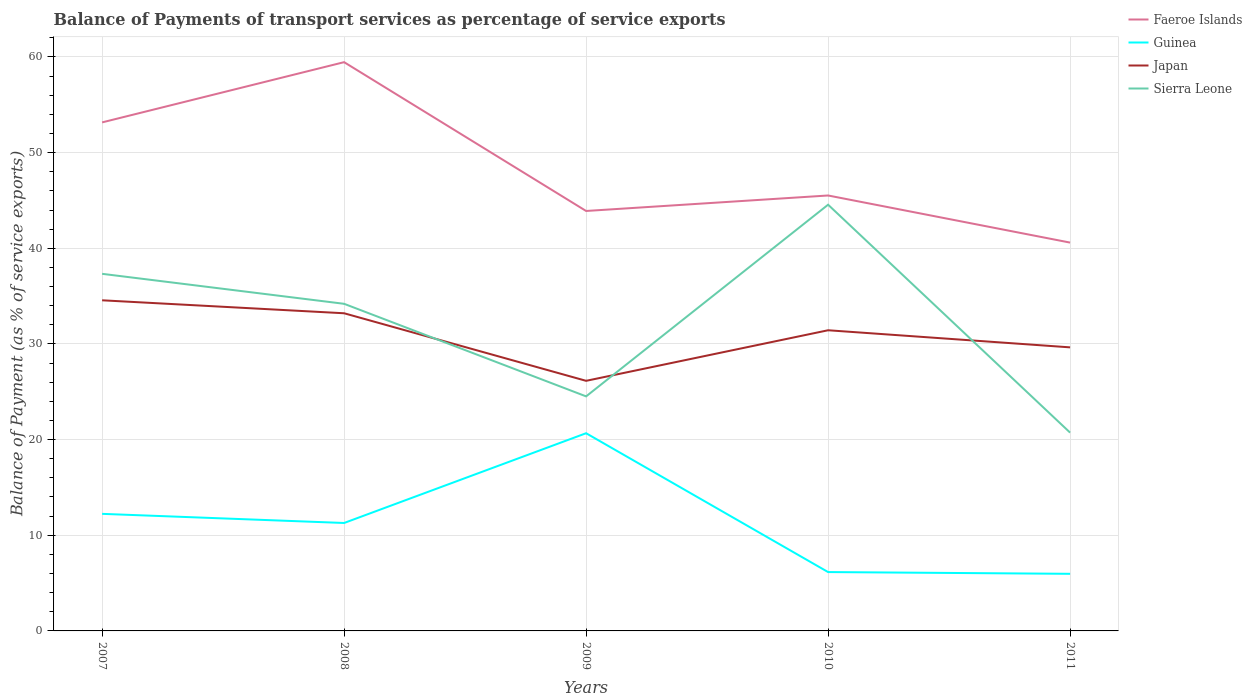Does the line corresponding to Sierra Leone intersect with the line corresponding to Japan?
Provide a succinct answer. Yes. Across all years, what is the maximum balance of payments of transport services in Sierra Leone?
Offer a terse response. 20.73. In which year was the balance of payments of transport services in Faeroe Islands maximum?
Provide a succinct answer. 2011. What is the total balance of payments of transport services in Japan in the graph?
Provide a short and direct response. 8.42. What is the difference between the highest and the second highest balance of payments of transport services in Guinea?
Keep it short and to the point. 14.7. Is the balance of payments of transport services in Guinea strictly greater than the balance of payments of transport services in Faeroe Islands over the years?
Provide a short and direct response. Yes. What is the difference between two consecutive major ticks on the Y-axis?
Provide a short and direct response. 10. How many legend labels are there?
Make the answer very short. 4. How are the legend labels stacked?
Keep it short and to the point. Vertical. What is the title of the graph?
Provide a succinct answer. Balance of Payments of transport services as percentage of service exports. Does "Nicaragua" appear as one of the legend labels in the graph?
Make the answer very short. No. What is the label or title of the X-axis?
Your response must be concise. Years. What is the label or title of the Y-axis?
Your answer should be very brief. Balance of Payment (as % of service exports). What is the Balance of Payment (as % of service exports) of Faeroe Islands in 2007?
Provide a succinct answer. 53.16. What is the Balance of Payment (as % of service exports) in Guinea in 2007?
Your answer should be compact. 12.24. What is the Balance of Payment (as % of service exports) in Japan in 2007?
Provide a short and direct response. 34.56. What is the Balance of Payment (as % of service exports) in Sierra Leone in 2007?
Offer a terse response. 37.33. What is the Balance of Payment (as % of service exports) of Faeroe Islands in 2008?
Make the answer very short. 59.46. What is the Balance of Payment (as % of service exports) in Guinea in 2008?
Offer a terse response. 11.28. What is the Balance of Payment (as % of service exports) in Japan in 2008?
Give a very brief answer. 33.21. What is the Balance of Payment (as % of service exports) in Sierra Leone in 2008?
Give a very brief answer. 34.2. What is the Balance of Payment (as % of service exports) of Faeroe Islands in 2009?
Your answer should be very brief. 43.9. What is the Balance of Payment (as % of service exports) in Guinea in 2009?
Keep it short and to the point. 20.67. What is the Balance of Payment (as % of service exports) in Japan in 2009?
Your response must be concise. 26.14. What is the Balance of Payment (as % of service exports) of Sierra Leone in 2009?
Your answer should be very brief. 24.52. What is the Balance of Payment (as % of service exports) in Faeroe Islands in 2010?
Your response must be concise. 45.52. What is the Balance of Payment (as % of service exports) in Guinea in 2010?
Keep it short and to the point. 6.15. What is the Balance of Payment (as % of service exports) in Japan in 2010?
Your answer should be compact. 31.43. What is the Balance of Payment (as % of service exports) in Sierra Leone in 2010?
Make the answer very short. 44.56. What is the Balance of Payment (as % of service exports) of Faeroe Islands in 2011?
Your answer should be compact. 40.59. What is the Balance of Payment (as % of service exports) in Guinea in 2011?
Make the answer very short. 5.97. What is the Balance of Payment (as % of service exports) of Japan in 2011?
Ensure brevity in your answer.  29.64. What is the Balance of Payment (as % of service exports) of Sierra Leone in 2011?
Provide a short and direct response. 20.73. Across all years, what is the maximum Balance of Payment (as % of service exports) of Faeroe Islands?
Give a very brief answer. 59.46. Across all years, what is the maximum Balance of Payment (as % of service exports) of Guinea?
Offer a terse response. 20.67. Across all years, what is the maximum Balance of Payment (as % of service exports) in Japan?
Your answer should be very brief. 34.56. Across all years, what is the maximum Balance of Payment (as % of service exports) of Sierra Leone?
Your answer should be very brief. 44.56. Across all years, what is the minimum Balance of Payment (as % of service exports) of Faeroe Islands?
Make the answer very short. 40.59. Across all years, what is the minimum Balance of Payment (as % of service exports) of Guinea?
Make the answer very short. 5.97. Across all years, what is the minimum Balance of Payment (as % of service exports) in Japan?
Offer a terse response. 26.14. Across all years, what is the minimum Balance of Payment (as % of service exports) in Sierra Leone?
Your answer should be compact. 20.73. What is the total Balance of Payment (as % of service exports) of Faeroe Islands in the graph?
Your answer should be compact. 242.63. What is the total Balance of Payment (as % of service exports) of Guinea in the graph?
Ensure brevity in your answer.  56.31. What is the total Balance of Payment (as % of service exports) in Japan in the graph?
Your answer should be very brief. 154.99. What is the total Balance of Payment (as % of service exports) in Sierra Leone in the graph?
Make the answer very short. 161.33. What is the difference between the Balance of Payment (as % of service exports) in Faeroe Islands in 2007 and that in 2008?
Keep it short and to the point. -6.3. What is the difference between the Balance of Payment (as % of service exports) in Guinea in 2007 and that in 2008?
Your answer should be very brief. 0.96. What is the difference between the Balance of Payment (as % of service exports) in Japan in 2007 and that in 2008?
Ensure brevity in your answer.  1.36. What is the difference between the Balance of Payment (as % of service exports) of Sierra Leone in 2007 and that in 2008?
Make the answer very short. 3.14. What is the difference between the Balance of Payment (as % of service exports) of Faeroe Islands in 2007 and that in 2009?
Your response must be concise. 9.26. What is the difference between the Balance of Payment (as % of service exports) of Guinea in 2007 and that in 2009?
Your answer should be compact. -8.43. What is the difference between the Balance of Payment (as % of service exports) in Japan in 2007 and that in 2009?
Provide a short and direct response. 8.42. What is the difference between the Balance of Payment (as % of service exports) of Sierra Leone in 2007 and that in 2009?
Offer a very short reply. 12.81. What is the difference between the Balance of Payment (as % of service exports) of Faeroe Islands in 2007 and that in 2010?
Your answer should be very brief. 7.64. What is the difference between the Balance of Payment (as % of service exports) of Guinea in 2007 and that in 2010?
Provide a short and direct response. 6.09. What is the difference between the Balance of Payment (as % of service exports) of Japan in 2007 and that in 2010?
Keep it short and to the point. 3.13. What is the difference between the Balance of Payment (as % of service exports) of Sierra Leone in 2007 and that in 2010?
Offer a very short reply. -7.22. What is the difference between the Balance of Payment (as % of service exports) in Faeroe Islands in 2007 and that in 2011?
Offer a terse response. 12.57. What is the difference between the Balance of Payment (as % of service exports) in Guinea in 2007 and that in 2011?
Your answer should be compact. 6.27. What is the difference between the Balance of Payment (as % of service exports) in Japan in 2007 and that in 2011?
Offer a terse response. 4.92. What is the difference between the Balance of Payment (as % of service exports) in Sierra Leone in 2007 and that in 2011?
Offer a very short reply. 16.6. What is the difference between the Balance of Payment (as % of service exports) in Faeroe Islands in 2008 and that in 2009?
Give a very brief answer. 15.56. What is the difference between the Balance of Payment (as % of service exports) in Guinea in 2008 and that in 2009?
Ensure brevity in your answer.  -9.38. What is the difference between the Balance of Payment (as % of service exports) in Japan in 2008 and that in 2009?
Keep it short and to the point. 7.06. What is the difference between the Balance of Payment (as % of service exports) of Sierra Leone in 2008 and that in 2009?
Your response must be concise. 9.68. What is the difference between the Balance of Payment (as % of service exports) of Faeroe Islands in 2008 and that in 2010?
Offer a terse response. 13.94. What is the difference between the Balance of Payment (as % of service exports) in Guinea in 2008 and that in 2010?
Offer a very short reply. 5.13. What is the difference between the Balance of Payment (as % of service exports) in Japan in 2008 and that in 2010?
Give a very brief answer. 1.78. What is the difference between the Balance of Payment (as % of service exports) in Sierra Leone in 2008 and that in 2010?
Keep it short and to the point. -10.36. What is the difference between the Balance of Payment (as % of service exports) of Faeroe Islands in 2008 and that in 2011?
Offer a very short reply. 18.86. What is the difference between the Balance of Payment (as % of service exports) in Guinea in 2008 and that in 2011?
Provide a short and direct response. 5.31. What is the difference between the Balance of Payment (as % of service exports) in Japan in 2008 and that in 2011?
Make the answer very short. 3.56. What is the difference between the Balance of Payment (as % of service exports) in Sierra Leone in 2008 and that in 2011?
Ensure brevity in your answer.  13.47. What is the difference between the Balance of Payment (as % of service exports) of Faeroe Islands in 2009 and that in 2010?
Keep it short and to the point. -1.62. What is the difference between the Balance of Payment (as % of service exports) in Guinea in 2009 and that in 2010?
Ensure brevity in your answer.  14.51. What is the difference between the Balance of Payment (as % of service exports) of Japan in 2009 and that in 2010?
Make the answer very short. -5.29. What is the difference between the Balance of Payment (as % of service exports) of Sierra Leone in 2009 and that in 2010?
Your response must be concise. -20.04. What is the difference between the Balance of Payment (as % of service exports) in Faeroe Islands in 2009 and that in 2011?
Provide a succinct answer. 3.31. What is the difference between the Balance of Payment (as % of service exports) of Guinea in 2009 and that in 2011?
Keep it short and to the point. 14.7. What is the difference between the Balance of Payment (as % of service exports) in Japan in 2009 and that in 2011?
Give a very brief answer. -3.5. What is the difference between the Balance of Payment (as % of service exports) in Sierra Leone in 2009 and that in 2011?
Ensure brevity in your answer.  3.79. What is the difference between the Balance of Payment (as % of service exports) in Faeroe Islands in 2010 and that in 2011?
Keep it short and to the point. 4.92. What is the difference between the Balance of Payment (as % of service exports) in Guinea in 2010 and that in 2011?
Provide a succinct answer. 0.18. What is the difference between the Balance of Payment (as % of service exports) of Japan in 2010 and that in 2011?
Your answer should be very brief. 1.79. What is the difference between the Balance of Payment (as % of service exports) of Sierra Leone in 2010 and that in 2011?
Ensure brevity in your answer.  23.83. What is the difference between the Balance of Payment (as % of service exports) of Faeroe Islands in 2007 and the Balance of Payment (as % of service exports) of Guinea in 2008?
Ensure brevity in your answer.  41.88. What is the difference between the Balance of Payment (as % of service exports) in Faeroe Islands in 2007 and the Balance of Payment (as % of service exports) in Japan in 2008?
Your response must be concise. 19.95. What is the difference between the Balance of Payment (as % of service exports) in Faeroe Islands in 2007 and the Balance of Payment (as % of service exports) in Sierra Leone in 2008?
Offer a terse response. 18.96. What is the difference between the Balance of Payment (as % of service exports) of Guinea in 2007 and the Balance of Payment (as % of service exports) of Japan in 2008?
Keep it short and to the point. -20.97. What is the difference between the Balance of Payment (as % of service exports) in Guinea in 2007 and the Balance of Payment (as % of service exports) in Sierra Leone in 2008?
Offer a terse response. -21.96. What is the difference between the Balance of Payment (as % of service exports) of Japan in 2007 and the Balance of Payment (as % of service exports) of Sierra Leone in 2008?
Your response must be concise. 0.37. What is the difference between the Balance of Payment (as % of service exports) in Faeroe Islands in 2007 and the Balance of Payment (as % of service exports) in Guinea in 2009?
Provide a short and direct response. 32.49. What is the difference between the Balance of Payment (as % of service exports) of Faeroe Islands in 2007 and the Balance of Payment (as % of service exports) of Japan in 2009?
Your answer should be very brief. 27.02. What is the difference between the Balance of Payment (as % of service exports) in Faeroe Islands in 2007 and the Balance of Payment (as % of service exports) in Sierra Leone in 2009?
Keep it short and to the point. 28.64. What is the difference between the Balance of Payment (as % of service exports) of Guinea in 2007 and the Balance of Payment (as % of service exports) of Japan in 2009?
Ensure brevity in your answer.  -13.91. What is the difference between the Balance of Payment (as % of service exports) in Guinea in 2007 and the Balance of Payment (as % of service exports) in Sierra Leone in 2009?
Your answer should be compact. -12.28. What is the difference between the Balance of Payment (as % of service exports) in Japan in 2007 and the Balance of Payment (as % of service exports) in Sierra Leone in 2009?
Give a very brief answer. 10.04. What is the difference between the Balance of Payment (as % of service exports) in Faeroe Islands in 2007 and the Balance of Payment (as % of service exports) in Guinea in 2010?
Your answer should be very brief. 47.01. What is the difference between the Balance of Payment (as % of service exports) in Faeroe Islands in 2007 and the Balance of Payment (as % of service exports) in Japan in 2010?
Offer a very short reply. 21.73. What is the difference between the Balance of Payment (as % of service exports) of Faeroe Islands in 2007 and the Balance of Payment (as % of service exports) of Sierra Leone in 2010?
Ensure brevity in your answer.  8.6. What is the difference between the Balance of Payment (as % of service exports) of Guinea in 2007 and the Balance of Payment (as % of service exports) of Japan in 2010?
Your answer should be compact. -19.19. What is the difference between the Balance of Payment (as % of service exports) of Guinea in 2007 and the Balance of Payment (as % of service exports) of Sierra Leone in 2010?
Give a very brief answer. -32.32. What is the difference between the Balance of Payment (as % of service exports) of Japan in 2007 and the Balance of Payment (as % of service exports) of Sierra Leone in 2010?
Make the answer very short. -9.99. What is the difference between the Balance of Payment (as % of service exports) of Faeroe Islands in 2007 and the Balance of Payment (as % of service exports) of Guinea in 2011?
Your response must be concise. 47.19. What is the difference between the Balance of Payment (as % of service exports) of Faeroe Islands in 2007 and the Balance of Payment (as % of service exports) of Japan in 2011?
Provide a short and direct response. 23.52. What is the difference between the Balance of Payment (as % of service exports) of Faeroe Islands in 2007 and the Balance of Payment (as % of service exports) of Sierra Leone in 2011?
Provide a succinct answer. 32.43. What is the difference between the Balance of Payment (as % of service exports) in Guinea in 2007 and the Balance of Payment (as % of service exports) in Japan in 2011?
Ensure brevity in your answer.  -17.4. What is the difference between the Balance of Payment (as % of service exports) of Guinea in 2007 and the Balance of Payment (as % of service exports) of Sierra Leone in 2011?
Provide a short and direct response. -8.49. What is the difference between the Balance of Payment (as % of service exports) of Japan in 2007 and the Balance of Payment (as % of service exports) of Sierra Leone in 2011?
Give a very brief answer. 13.83. What is the difference between the Balance of Payment (as % of service exports) in Faeroe Islands in 2008 and the Balance of Payment (as % of service exports) in Guinea in 2009?
Offer a very short reply. 38.79. What is the difference between the Balance of Payment (as % of service exports) in Faeroe Islands in 2008 and the Balance of Payment (as % of service exports) in Japan in 2009?
Offer a very short reply. 33.31. What is the difference between the Balance of Payment (as % of service exports) in Faeroe Islands in 2008 and the Balance of Payment (as % of service exports) in Sierra Leone in 2009?
Provide a succinct answer. 34.94. What is the difference between the Balance of Payment (as % of service exports) of Guinea in 2008 and the Balance of Payment (as % of service exports) of Japan in 2009?
Ensure brevity in your answer.  -14.86. What is the difference between the Balance of Payment (as % of service exports) of Guinea in 2008 and the Balance of Payment (as % of service exports) of Sierra Leone in 2009?
Offer a terse response. -13.24. What is the difference between the Balance of Payment (as % of service exports) in Japan in 2008 and the Balance of Payment (as % of service exports) in Sierra Leone in 2009?
Offer a terse response. 8.69. What is the difference between the Balance of Payment (as % of service exports) of Faeroe Islands in 2008 and the Balance of Payment (as % of service exports) of Guinea in 2010?
Give a very brief answer. 53.3. What is the difference between the Balance of Payment (as % of service exports) of Faeroe Islands in 2008 and the Balance of Payment (as % of service exports) of Japan in 2010?
Offer a very short reply. 28.03. What is the difference between the Balance of Payment (as % of service exports) in Faeroe Islands in 2008 and the Balance of Payment (as % of service exports) in Sierra Leone in 2010?
Your answer should be compact. 14.9. What is the difference between the Balance of Payment (as % of service exports) of Guinea in 2008 and the Balance of Payment (as % of service exports) of Japan in 2010?
Your answer should be compact. -20.15. What is the difference between the Balance of Payment (as % of service exports) of Guinea in 2008 and the Balance of Payment (as % of service exports) of Sierra Leone in 2010?
Keep it short and to the point. -33.27. What is the difference between the Balance of Payment (as % of service exports) of Japan in 2008 and the Balance of Payment (as % of service exports) of Sierra Leone in 2010?
Offer a very short reply. -11.35. What is the difference between the Balance of Payment (as % of service exports) in Faeroe Islands in 2008 and the Balance of Payment (as % of service exports) in Guinea in 2011?
Offer a terse response. 53.49. What is the difference between the Balance of Payment (as % of service exports) of Faeroe Islands in 2008 and the Balance of Payment (as % of service exports) of Japan in 2011?
Offer a very short reply. 29.81. What is the difference between the Balance of Payment (as % of service exports) of Faeroe Islands in 2008 and the Balance of Payment (as % of service exports) of Sierra Leone in 2011?
Your answer should be compact. 38.73. What is the difference between the Balance of Payment (as % of service exports) in Guinea in 2008 and the Balance of Payment (as % of service exports) in Japan in 2011?
Make the answer very short. -18.36. What is the difference between the Balance of Payment (as % of service exports) of Guinea in 2008 and the Balance of Payment (as % of service exports) of Sierra Leone in 2011?
Make the answer very short. -9.45. What is the difference between the Balance of Payment (as % of service exports) of Japan in 2008 and the Balance of Payment (as % of service exports) of Sierra Leone in 2011?
Your response must be concise. 12.48. What is the difference between the Balance of Payment (as % of service exports) of Faeroe Islands in 2009 and the Balance of Payment (as % of service exports) of Guinea in 2010?
Provide a short and direct response. 37.75. What is the difference between the Balance of Payment (as % of service exports) of Faeroe Islands in 2009 and the Balance of Payment (as % of service exports) of Japan in 2010?
Provide a succinct answer. 12.47. What is the difference between the Balance of Payment (as % of service exports) in Faeroe Islands in 2009 and the Balance of Payment (as % of service exports) in Sierra Leone in 2010?
Keep it short and to the point. -0.66. What is the difference between the Balance of Payment (as % of service exports) of Guinea in 2009 and the Balance of Payment (as % of service exports) of Japan in 2010?
Your response must be concise. -10.76. What is the difference between the Balance of Payment (as % of service exports) of Guinea in 2009 and the Balance of Payment (as % of service exports) of Sierra Leone in 2010?
Your response must be concise. -23.89. What is the difference between the Balance of Payment (as % of service exports) of Japan in 2009 and the Balance of Payment (as % of service exports) of Sierra Leone in 2010?
Ensure brevity in your answer.  -18.41. What is the difference between the Balance of Payment (as % of service exports) in Faeroe Islands in 2009 and the Balance of Payment (as % of service exports) in Guinea in 2011?
Provide a succinct answer. 37.93. What is the difference between the Balance of Payment (as % of service exports) in Faeroe Islands in 2009 and the Balance of Payment (as % of service exports) in Japan in 2011?
Make the answer very short. 14.26. What is the difference between the Balance of Payment (as % of service exports) in Faeroe Islands in 2009 and the Balance of Payment (as % of service exports) in Sierra Leone in 2011?
Ensure brevity in your answer.  23.17. What is the difference between the Balance of Payment (as % of service exports) of Guinea in 2009 and the Balance of Payment (as % of service exports) of Japan in 2011?
Keep it short and to the point. -8.98. What is the difference between the Balance of Payment (as % of service exports) of Guinea in 2009 and the Balance of Payment (as % of service exports) of Sierra Leone in 2011?
Keep it short and to the point. -0.06. What is the difference between the Balance of Payment (as % of service exports) in Japan in 2009 and the Balance of Payment (as % of service exports) in Sierra Leone in 2011?
Your response must be concise. 5.41. What is the difference between the Balance of Payment (as % of service exports) in Faeroe Islands in 2010 and the Balance of Payment (as % of service exports) in Guinea in 2011?
Offer a terse response. 39.55. What is the difference between the Balance of Payment (as % of service exports) in Faeroe Islands in 2010 and the Balance of Payment (as % of service exports) in Japan in 2011?
Give a very brief answer. 15.88. What is the difference between the Balance of Payment (as % of service exports) of Faeroe Islands in 2010 and the Balance of Payment (as % of service exports) of Sierra Leone in 2011?
Your answer should be compact. 24.79. What is the difference between the Balance of Payment (as % of service exports) in Guinea in 2010 and the Balance of Payment (as % of service exports) in Japan in 2011?
Ensure brevity in your answer.  -23.49. What is the difference between the Balance of Payment (as % of service exports) in Guinea in 2010 and the Balance of Payment (as % of service exports) in Sierra Leone in 2011?
Make the answer very short. -14.58. What is the difference between the Balance of Payment (as % of service exports) of Japan in 2010 and the Balance of Payment (as % of service exports) of Sierra Leone in 2011?
Provide a short and direct response. 10.7. What is the average Balance of Payment (as % of service exports) of Faeroe Islands per year?
Keep it short and to the point. 48.53. What is the average Balance of Payment (as % of service exports) in Guinea per year?
Your answer should be very brief. 11.26. What is the average Balance of Payment (as % of service exports) of Japan per year?
Keep it short and to the point. 31. What is the average Balance of Payment (as % of service exports) in Sierra Leone per year?
Provide a short and direct response. 32.27. In the year 2007, what is the difference between the Balance of Payment (as % of service exports) in Faeroe Islands and Balance of Payment (as % of service exports) in Guinea?
Your answer should be compact. 40.92. In the year 2007, what is the difference between the Balance of Payment (as % of service exports) in Faeroe Islands and Balance of Payment (as % of service exports) in Japan?
Your response must be concise. 18.6. In the year 2007, what is the difference between the Balance of Payment (as % of service exports) in Faeroe Islands and Balance of Payment (as % of service exports) in Sierra Leone?
Provide a succinct answer. 15.83. In the year 2007, what is the difference between the Balance of Payment (as % of service exports) of Guinea and Balance of Payment (as % of service exports) of Japan?
Offer a terse response. -22.32. In the year 2007, what is the difference between the Balance of Payment (as % of service exports) in Guinea and Balance of Payment (as % of service exports) in Sierra Leone?
Your answer should be compact. -25.09. In the year 2007, what is the difference between the Balance of Payment (as % of service exports) in Japan and Balance of Payment (as % of service exports) in Sierra Leone?
Your answer should be compact. -2.77. In the year 2008, what is the difference between the Balance of Payment (as % of service exports) in Faeroe Islands and Balance of Payment (as % of service exports) in Guinea?
Offer a terse response. 48.17. In the year 2008, what is the difference between the Balance of Payment (as % of service exports) in Faeroe Islands and Balance of Payment (as % of service exports) in Japan?
Keep it short and to the point. 26.25. In the year 2008, what is the difference between the Balance of Payment (as % of service exports) in Faeroe Islands and Balance of Payment (as % of service exports) in Sierra Leone?
Your answer should be compact. 25.26. In the year 2008, what is the difference between the Balance of Payment (as % of service exports) of Guinea and Balance of Payment (as % of service exports) of Japan?
Your answer should be compact. -21.92. In the year 2008, what is the difference between the Balance of Payment (as % of service exports) of Guinea and Balance of Payment (as % of service exports) of Sierra Leone?
Provide a succinct answer. -22.91. In the year 2008, what is the difference between the Balance of Payment (as % of service exports) of Japan and Balance of Payment (as % of service exports) of Sierra Leone?
Offer a very short reply. -0.99. In the year 2009, what is the difference between the Balance of Payment (as % of service exports) in Faeroe Islands and Balance of Payment (as % of service exports) in Guinea?
Give a very brief answer. 23.23. In the year 2009, what is the difference between the Balance of Payment (as % of service exports) of Faeroe Islands and Balance of Payment (as % of service exports) of Japan?
Make the answer very short. 17.76. In the year 2009, what is the difference between the Balance of Payment (as % of service exports) in Faeroe Islands and Balance of Payment (as % of service exports) in Sierra Leone?
Your answer should be very brief. 19.38. In the year 2009, what is the difference between the Balance of Payment (as % of service exports) in Guinea and Balance of Payment (as % of service exports) in Japan?
Your answer should be compact. -5.48. In the year 2009, what is the difference between the Balance of Payment (as % of service exports) of Guinea and Balance of Payment (as % of service exports) of Sierra Leone?
Your answer should be very brief. -3.85. In the year 2009, what is the difference between the Balance of Payment (as % of service exports) in Japan and Balance of Payment (as % of service exports) in Sierra Leone?
Your answer should be compact. 1.63. In the year 2010, what is the difference between the Balance of Payment (as % of service exports) in Faeroe Islands and Balance of Payment (as % of service exports) in Guinea?
Ensure brevity in your answer.  39.37. In the year 2010, what is the difference between the Balance of Payment (as % of service exports) in Faeroe Islands and Balance of Payment (as % of service exports) in Japan?
Make the answer very short. 14.09. In the year 2010, what is the difference between the Balance of Payment (as % of service exports) in Faeroe Islands and Balance of Payment (as % of service exports) in Sierra Leone?
Make the answer very short. 0.96. In the year 2010, what is the difference between the Balance of Payment (as % of service exports) in Guinea and Balance of Payment (as % of service exports) in Japan?
Ensure brevity in your answer.  -25.28. In the year 2010, what is the difference between the Balance of Payment (as % of service exports) of Guinea and Balance of Payment (as % of service exports) of Sierra Leone?
Offer a very short reply. -38.4. In the year 2010, what is the difference between the Balance of Payment (as % of service exports) of Japan and Balance of Payment (as % of service exports) of Sierra Leone?
Offer a terse response. -13.12. In the year 2011, what is the difference between the Balance of Payment (as % of service exports) of Faeroe Islands and Balance of Payment (as % of service exports) of Guinea?
Offer a terse response. 34.62. In the year 2011, what is the difference between the Balance of Payment (as % of service exports) in Faeroe Islands and Balance of Payment (as % of service exports) in Japan?
Provide a succinct answer. 10.95. In the year 2011, what is the difference between the Balance of Payment (as % of service exports) of Faeroe Islands and Balance of Payment (as % of service exports) of Sierra Leone?
Your response must be concise. 19.87. In the year 2011, what is the difference between the Balance of Payment (as % of service exports) of Guinea and Balance of Payment (as % of service exports) of Japan?
Give a very brief answer. -23.67. In the year 2011, what is the difference between the Balance of Payment (as % of service exports) of Guinea and Balance of Payment (as % of service exports) of Sierra Leone?
Your answer should be compact. -14.76. In the year 2011, what is the difference between the Balance of Payment (as % of service exports) of Japan and Balance of Payment (as % of service exports) of Sierra Leone?
Make the answer very short. 8.91. What is the ratio of the Balance of Payment (as % of service exports) of Faeroe Islands in 2007 to that in 2008?
Make the answer very short. 0.89. What is the ratio of the Balance of Payment (as % of service exports) of Guinea in 2007 to that in 2008?
Your answer should be compact. 1.08. What is the ratio of the Balance of Payment (as % of service exports) in Japan in 2007 to that in 2008?
Offer a very short reply. 1.04. What is the ratio of the Balance of Payment (as % of service exports) of Sierra Leone in 2007 to that in 2008?
Offer a terse response. 1.09. What is the ratio of the Balance of Payment (as % of service exports) of Faeroe Islands in 2007 to that in 2009?
Your answer should be very brief. 1.21. What is the ratio of the Balance of Payment (as % of service exports) in Guinea in 2007 to that in 2009?
Give a very brief answer. 0.59. What is the ratio of the Balance of Payment (as % of service exports) of Japan in 2007 to that in 2009?
Ensure brevity in your answer.  1.32. What is the ratio of the Balance of Payment (as % of service exports) in Sierra Leone in 2007 to that in 2009?
Your answer should be compact. 1.52. What is the ratio of the Balance of Payment (as % of service exports) of Faeroe Islands in 2007 to that in 2010?
Your answer should be compact. 1.17. What is the ratio of the Balance of Payment (as % of service exports) in Guinea in 2007 to that in 2010?
Provide a short and direct response. 1.99. What is the ratio of the Balance of Payment (as % of service exports) in Japan in 2007 to that in 2010?
Your response must be concise. 1.1. What is the ratio of the Balance of Payment (as % of service exports) of Sierra Leone in 2007 to that in 2010?
Provide a short and direct response. 0.84. What is the ratio of the Balance of Payment (as % of service exports) in Faeroe Islands in 2007 to that in 2011?
Your answer should be compact. 1.31. What is the ratio of the Balance of Payment (as % of service exports) in Guinea in 2007 to that in 2011?
Ensure brevity in your answer.  2.05. What is the ratio of the Balance of Payment (as % of service exports) of Japan in 2007 to that in 2011?
Make the answer very short. 1.17. What is the ratio of the Balance of Payment (as % of service exports) of Sierra Leone in 2007 to that in 2011?
Give a very brief answer. 1.8. What is the ratio of the Balance of Payment (as % of service exports) of Faeroe Islands in 2008 to that in 2009?
Give a very brief answer. 1.35. What is the ratio of the Balance of Payment (as % of service exports) in Guinea in 2008 to that in 2009?
Offer a terse response. 0.55. What is the ratio of the Balance of Payment (as % of service exports) of Japan in 2008 to that in 2009?
Keep it short and to the point. 1.27. What is the ratio of the Balance of Payment (as % of service exports) of Sierra Leone in 2008 to that in 2009?
Keep it short and to the point. 1.39. What is the ratio of the Balance of Payment (as % of service exports) in Faeroe Islands in 2008 to that in 2010?
Offer a very short reply. 1.31. What is the ratio of the Balance of Payment (as % of service exports) of Guinea in 2008 to that in 2010?
Provide a succinct answer. 1.83. What is the ratio of the Balance of Payment (as % of service exports) of Japan in 2008 to that in 2010?
Your answer should be compact. 1.06. What is the ratio of the Balance of Payment (as % of service exports) of Sierra Leone in 2008 to that in 2010?
Make the answer very short. 0.77. What is the ratio of the Balance of Payment (as % of service exports) in Faeroe Islands in 2008 to that in 2011?
Give a very brief answer. 1.46. What is the ratio of the Balance of Payment (as % of service exports) of Guinea in 2008 to that in 2011?
Ensure brevity in your answer.  1.89. What is the ratio of the Balance of Payment (as % of service exports) in Japan in 2008 to that in 2011?
Keep it short and to the point. 1.12. What is the ratio of the Balance of Payment (as % of service exports) of Sierra Leone in 2008 to that in 2011?
Offer a very short reply. 1.65. What is the ratio of the Balance of Payment (as % of service exports) of Faeroe Islands in 2009 to that in 2010?
Your answer should be compact. 0.96. What is the ratio of the Balance of Payment (as % of service exports) of Guinea in 2009 to that in 2010?
Provide a short and direct response. 3.36. What is the ratio of the Balance of Payment (as % of service exports) of Japan in 2009 to that in 2010?
Give a very brief answer. 0.83. What is the ratio of the Balance of Payment (as % of service exports) of Sierra Leone in 2009 to that in 2010?
Give a very brief answer. 0.55. What is the ratio of the Balance of Payment (as % of service exports) in Faeroe Islands in 2009 to that in 2011?
Keep it short and to the point. 1.08. What is the ratio of the Balance of Payment (as % of service exports) in Guinea in 2009 to that in 2011?
Make the answer very short. 3.46. What is the ratio of the Balance of Payment (as % of service exports) in Japan in 2009 to that in 2011?
Offer a terse response. 0.88. What is the ratio of the Balance of Payment (as % of service exports) of Sierra Leone in 2009 to that in 2011?
Keep it short and to the point. 1.18. What is the ratio of the Balance of Payment (as % of service exports) of Faeroe Islands in 2010 to that in 2011?
Your response must be concise. 1.12. What is the ratio of the Balance of Payment (as % of service exports) of Guinea in 2010 to that in 2011?
Ensure brevity in your answer.  1.03. What is the ratio of the Balance of Payment (as % of service exports) of Japan in 2010 to that in 2011?
Offer a terse response. 1.06. What is the ratio of the Balance of Payment (as % of service exports) of Sierra Leone in 2010 to that in 2011?
Keep it short and to the point. 2.15. What is the difference between the highest and the second highest Balance of Payment (as % of service exports) of Faeroe Islands?
Your answer should be very brief. 6.3. What is the difference between the highest and the second highest Balance of Payment (as % of service exports) in Guinea?
Provide a succinct answer. 8.43. What is the difference between the highest and the second highest Balance of Payment (as % of service exports) of Japan?
Your response must be concise. 1.36. What is the difference between the highest and the second highest Balance of Payment (as % of service exports) of Sierra Leone?
Provide a short and direct response. 7.22. What is the difference between the highest and the lowest Balance of Payment (as % of service exports) in Faeroe Islands?
Give a very brief answer. 18.86. What is the difference between the highest and the lowest Balance of Payment (as % of service exports) in Guinea?
Your answer should be very brief. 14.7. What is the difference between the highest and the lowest Balance of Payment (as % of service exports) in Japan?
Make the answer very short. 8.42. What is the difference between the highest and the lowest Balance of Payment (as % of service exports) in Sierra Leone?
Provide a short and direct response. 23.83. 